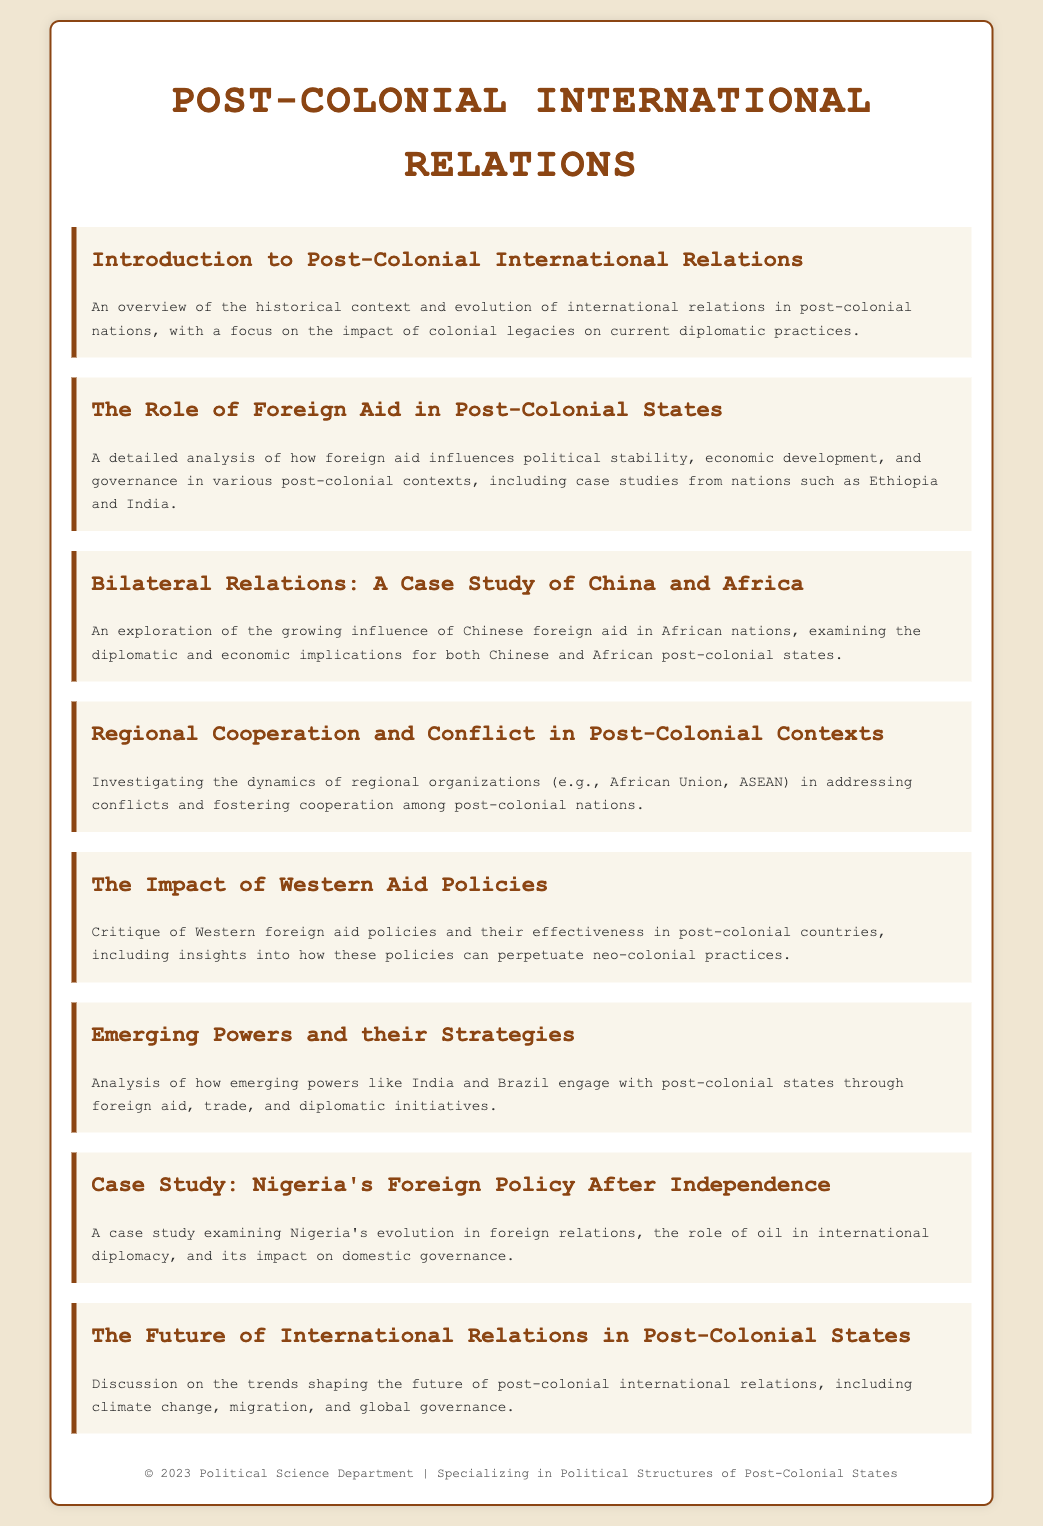What is the focus of the first menu item? The first menu item provides an overview of the historical context and evolution of international relations in post-colonial nations, highlighting the impact of colonial legacies on current diplomatic practices.
Answer: Historical context and evolution What case studies are mentioned regarding foreign aid? The document includes case studies from nations such as Ethiopia and India to illustrate how foreign aid influences political stability and governance.
Answer: Ethiopia and India Which countries are analyzed in the bilateral relations case study? The case study focuses on the growing influence of Chinese foreign aid in African nations, examining the implications for both Chinese and African post-colonial states.
Answer: China and Africa What is critiqued in the section on Western aid policies? The document critiques Western foreign aid policies and their effectiveness in post-colonial countries, also touching upon how these policies can perpetuate neo-colonial practices.
Answer: Effectiveness and neo-colonial practices Which region's organizations are investigated concerning conflict and cooperation? The dynamics of regional organizations in addressing conflicts and fostering cooperation among post-colonial nations include examples like the African Union and ASEAN.
Answer: African Union and ASEAN How does the document describe Nigeria's foreign policy? The case study examines Nigeria's evolution in foreign relations, including the role of oil in international diplomacy and its impact on domestic governance.
Answer: Role of oil in international diplomacy What future trends are discussed in the last menu item's overview? The document discusses trends shaping the future of post-colonial international relations, including climate change, migration, and global governance.
Answer: Climate change, migration, global governance 